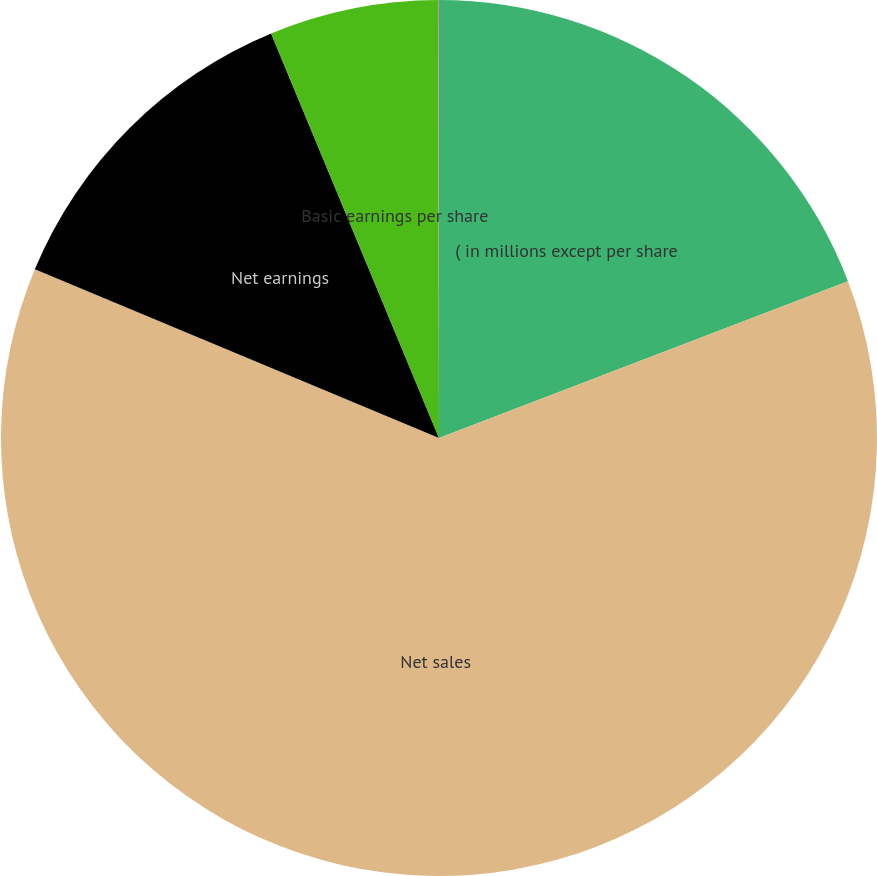<chart> <loc_0><loc_0><loc_500><loc_500><pie_chart><fcel>( in millions except per share<fcel>Net sales<fcel>Net earnings<fcel>Basic earnings per share<fcel>Diluted earnings per share<nl><fcel>19.17%<fcel>62.12%<fcel>12.44%<fcel>6.23%<fcel>0.03%<nl></chart> 